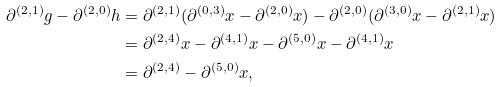<formula> <loc_0><loc_0><loc_500><loc_500>\partial ^ { ( 2 , 1 ) } g - \partial ^ { ( 2 , 0 ) } h & = \partial ^ { ( 2 , 1 ) } ( \partial ^ { ( 0 , 3 ) } x - \partial ^ { ( 2 , 0 ) } x ) - \partial ^ { ( 2 , 0 ) } ( \partial ^ { ( 3 , 0 ) } x - \partial ^ { ( 2 , 1 ) } x ) \\ & = \partial ^ { ( 2 , 4 ) } x - \partial ^ { ( 4 , 1 ) } x - \partial ^ { ( 5 , 0 ) } x - \partial ^ { ( 4 , 1 ) } x \\ & = \partial ^ { ( 2 , 4 ) } - \partial ^ { ( 5 , 0 ) } x ,</formula> 